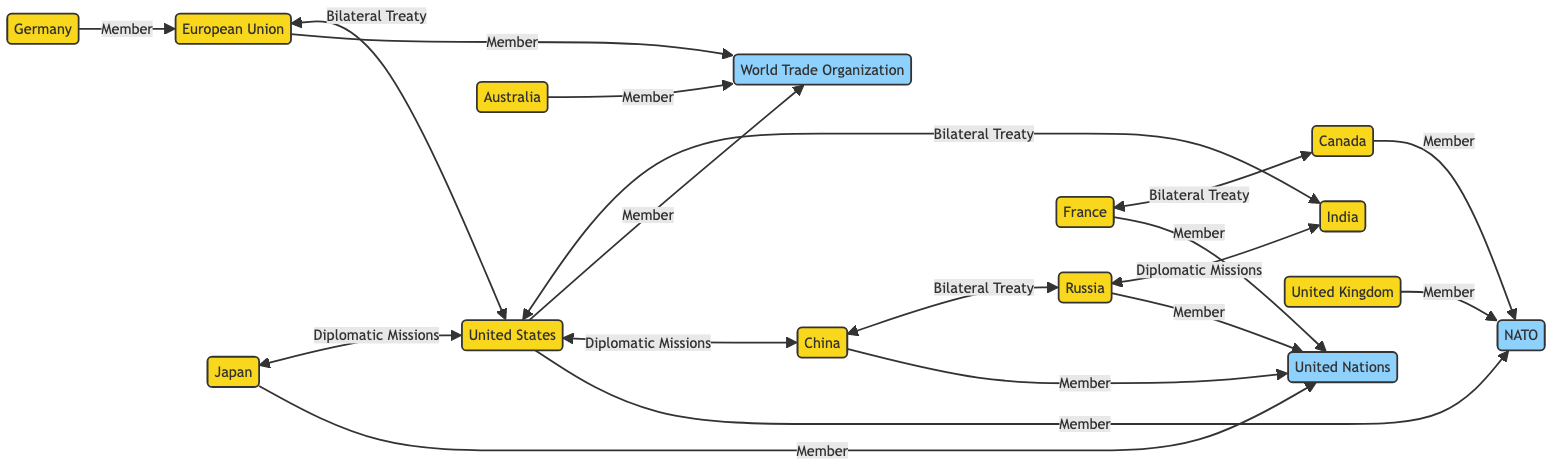What country is a member of NATO? From the diagram, it can be observed that both the United States and the United Kingdom are indicated as members of NATO. Therefore, when asked about a country that is a member of NATO, we can refer to either of these two countries.
Answer: United States Which country has a bilateral treaty with the United States? According to the diagram, there is a direct link indicating a bilateral treaty between the United States and India. This relationship highlights that these two countries have made agreements through a bilateral treaty.
Answer: India How many countries are involved in the diagram? By counting the unique entities represented as countries in the diagram, we can see there are a total of eight distinct countries: United States, Russia, China, India, Japan, Germany, United Kingdom, and France.
Answer: Eight Which organization does the European Union belong to? The diagram explicitly shows a membership link between the European Union and the World Trade Organization, indicating the EU’s affiliation with this organization.
Answer: World Trade Organization Which country has diplomatic missions established with China? The diagram illustrates that the United States has diplomatic missions established with China, indicating a form of diplomatic relations and representation between these two countries.
Answer: United States Which country has both diplomatic missions and a bilateral treaty with Russia? The diagram shows that India has a bilateral treaty with Russia and also a link to diplomatic missions between Russia and India. Thus, we conclude that India is the country that holds both types of relations with Russia.
Answer: India How many bilateral treaties are shown in the diagram? Upon examining the connections within the diagram, we can find that there are three distinct bilateral treaties illustrated: one between the United States and India, one between China and Russia, and one between France and Canada. Therefore, the total number of bilateral treaties represented is three.
Answer: Three What is the relationship between Germany and the European Union? The diagram indicates that Germany is a member of the European Union, which suggests a formal relationship where Germany is part of this larger political and economic organization.
Answer: Member Which international organization has the most members in the diagram? By analyzing the links, we can see that NATO appears to have three member countries (United States, United Kingdom, and Canada), while the United Nations and the World Trade Organization also have multiple members. However, since each of these organizations has its unique member configuration, the one with the most representation here in our view based on the direct links will be the United Nations, which shows a wider membership pattern overall in the context of this diagram.
Answer: United Nations 